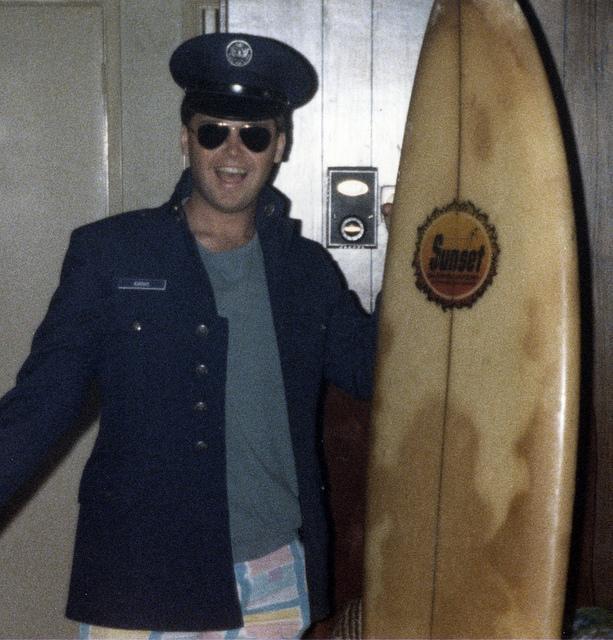How many people are there?
Give a very brief answer. 1. How many surfboards can be seen?
Give a very brief answer. 1. How many remotes are there?
Give a very brief answer. 0. 